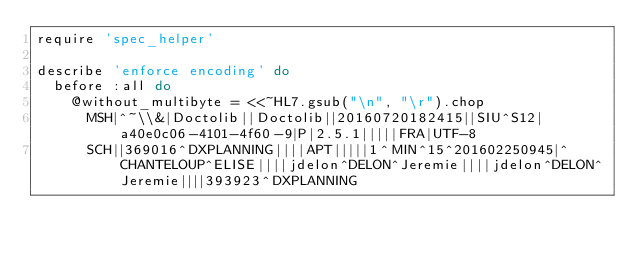Convert code to text. <code><loc_0><loc_0><loc_500><loc_500><_Ruby_>require 'spec_helper'

describe 'enforce encoding' do
  before :all do
    @without_multibyte = <<~HL7.gsub("\n", "\r").chop
      MSH|^~\\&|Doctolib||Doctolib||20160720182415||SIU^S12|a40e0c06-4101-4f60-9|P|2.5.1|||||FRA|UTF-8
      SCH||369016^DXPLANNING||||APT|||||1^MIN^15^201602250945|^CHANTELOUP^ELISE||||jdelon^DELON^Jeremie||||jdelon^DELON^Jeremie||||393923^DXPLANNING</code> 